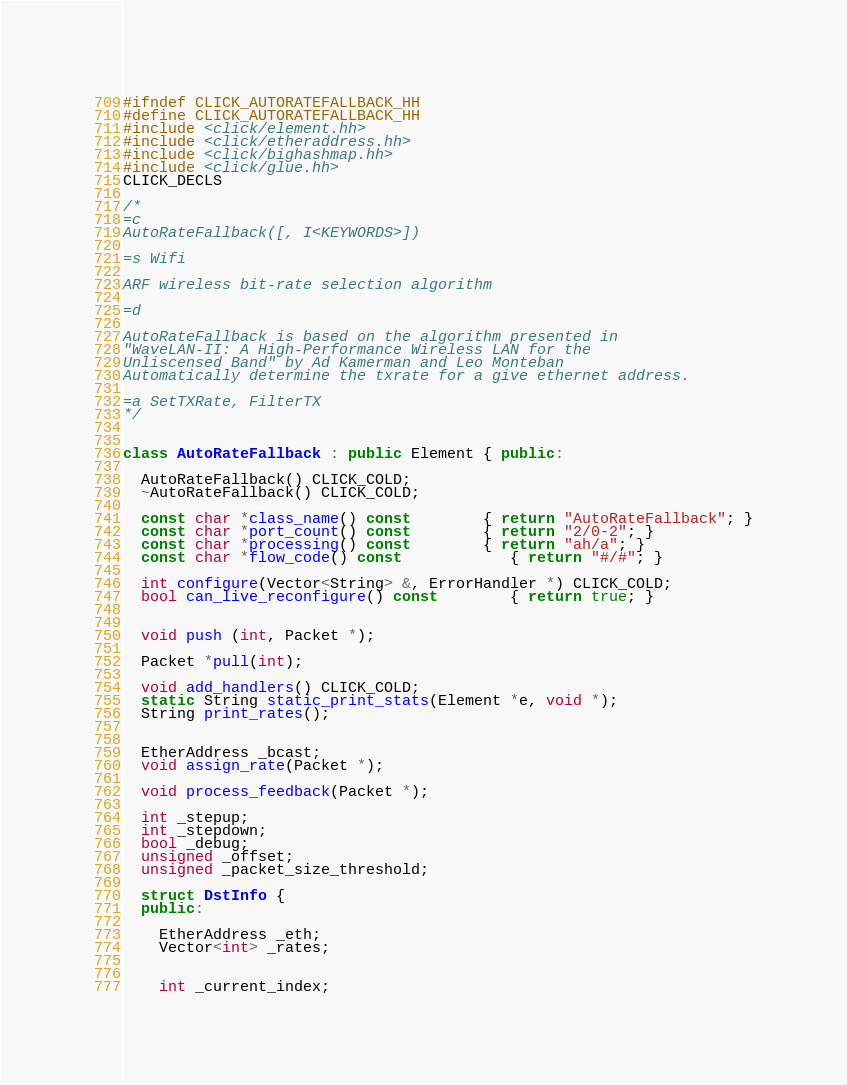<code> <loc_0><loc_0><loc_500><loc_500><_C++_>#ifndef CLICK_AUTORATEFALLBACK_HH
#define CLICK_AUTORATEFALLBACK_HH
#include <click/element.hh>
#include <click/etheraddress.hh>
#include <click/bighashmap.hh>
#include <click/glue.hh>
CLICK_DECLS

/*
=c
AutoRateFallback([, I<KEYWORDS>])

=s Wifi

ARF wireless bit-rate selection algorithm

=d

AutoRateFallback is based on the algorithm presented in
"WaveLAN-II: A High-Performance Wireless LAN for the
Unliscensed Band" by Ad Kamerman and Leo Monteban
Automatically determine the txrate for a give ethernet address.

=a SetTXRate, FilterTX
*/


class AutoRateFallback : public Element { public:

  AutoRateFallback() CLICK_COLD;
  ~AutoRateFallback() CLICK_COLD;

  const char *class_name() const		{ return "AutoRateFallback"; }
  const char *port_count() const		{ return "2/0-2"; }
  const char *processing() const		{ return "ah/a"; }
  const char *flow_code() const			{ return "#/#"; }

  int configure(Vector<String> &, ErrorHandler *) CLICK_COLD;
  bool can_live_reconfigure() const		{ return true; }


  void push (int, Packet *);

  Packet *pull(int);

  void add_handlers() CLICK_COLD;
  static String static_print_stats(Element *e, void *);
  String print_rates();


  EtherAddress _bcast;
  void assign_rate(Packet *);

  void process_feedback(Packet *);

  int _stepup;
  int _stepdown;
  bool _debug;
  unsigned _offset;
  unsigned _packet_size_threshold;

  struct DstInfo {
  public:

    EtherAddress _eth;
    Vector<int> _rates;


    int _current_index;</code> 